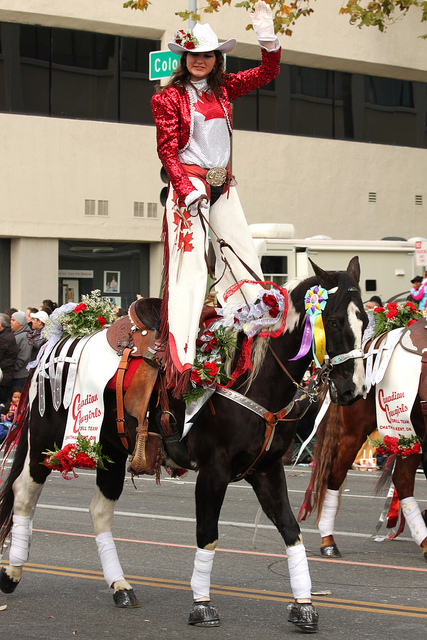What does the horse's posture tell you about its training or temperament? The horse appears calm and well-trained, standing steady in what could be a busy or noisy environment. Its head is held high, and it maintains a poised stature, indicating it is accustomed to events like this and has likely undergone significant training to be comfortable with crowds and festivities. 